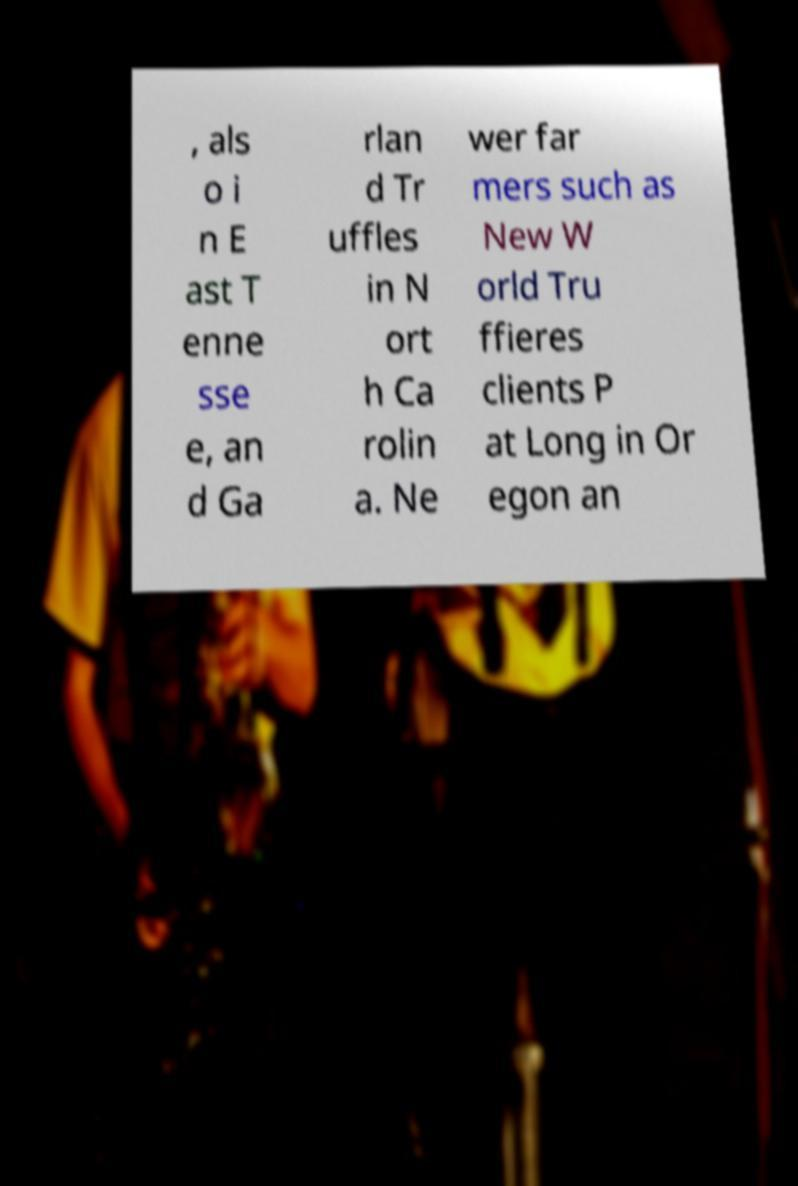I need the written content from this picture converted into text. Can you do that? , als o i n E ast T enne sse e, an d Ga rlan d Tr uffles in N ort h Ca rolin a. Ne wer far mers such as New W orld Tru ffieres clients P at Long in Or egon an 